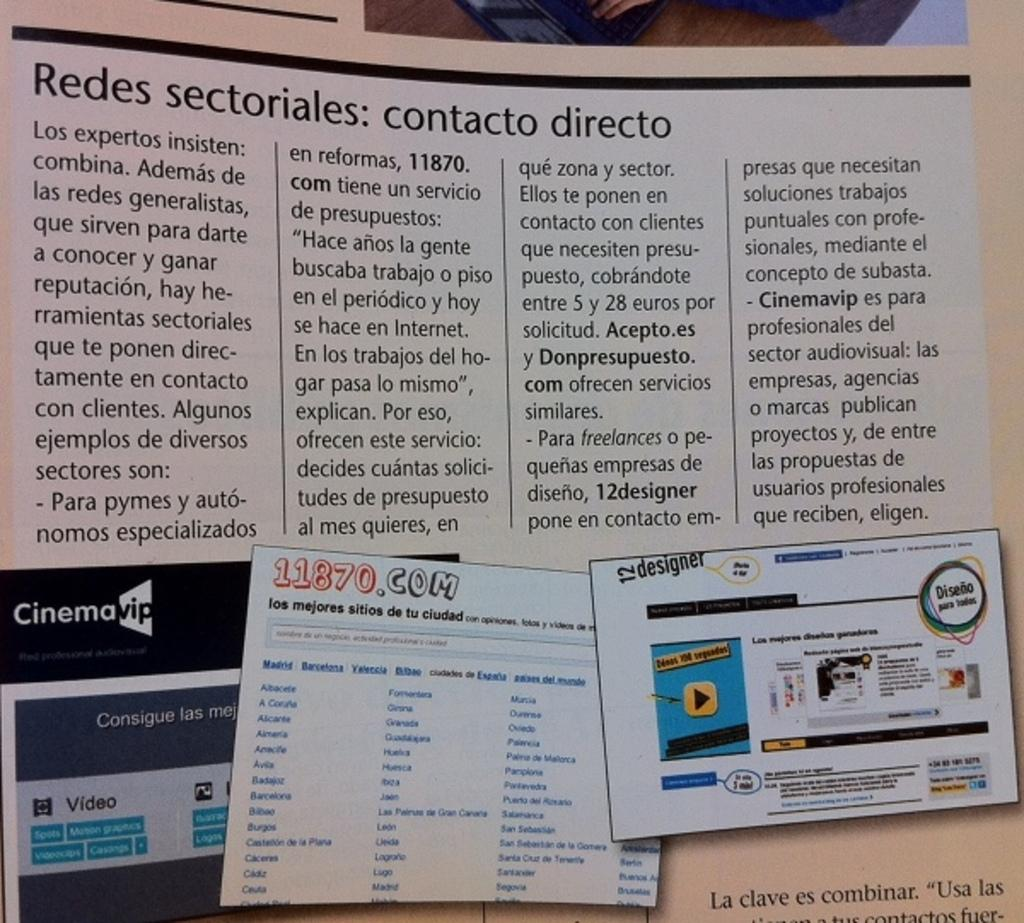Provide a one-sentence caption for the provided image. A 11870.com flyer is pinned to a board with various other flyers. 